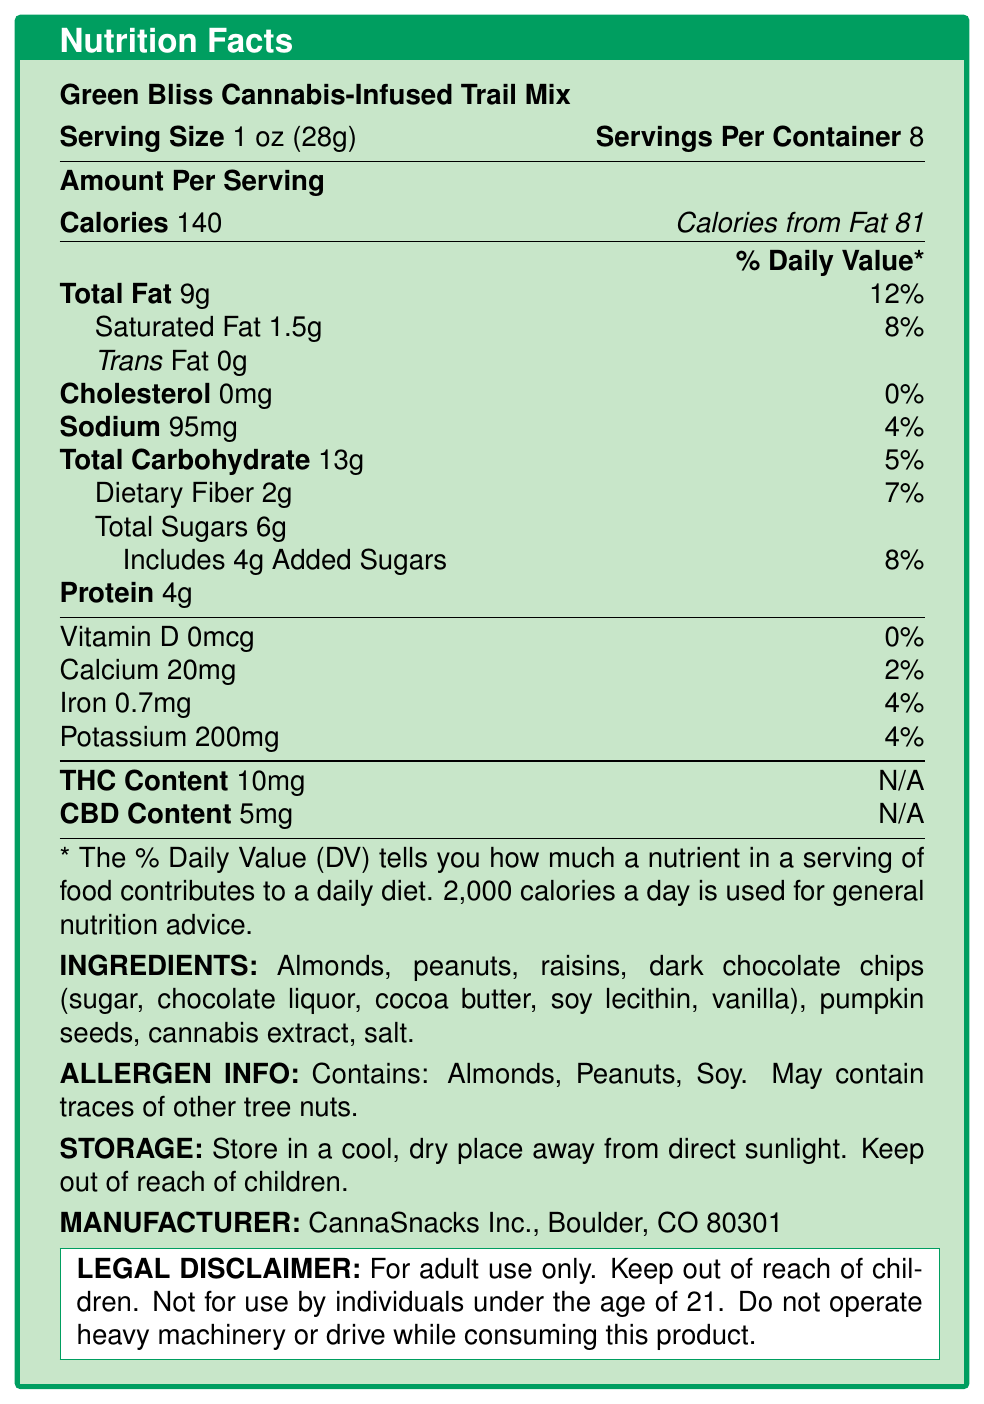what is the serving size for Green Bliss Cannabis-Infused Trail Mix? According to the document, the serving size is listed as "1 oz (28g)".
Answer: 1 oz (28g) how many calories are there per serving? The document states that each serving contains 140 calories.
Answer: 140 what is the total fat content per serving and its daily value percentage? The document specifies that each serving has 9g of total fat, which is 12% of the daily value.
Answer: 9g, 12% how much dietary fiber does each serving contain? According to the document, each serving contains 2g of dietary fiber.
Answer: 2g what are the ingredients in the product? The ingredients are listed clearly under the "INGREDIENTS:" section of the document.
Answer: Almonds, peanuts, raisins, dark chocolate chips (sugar, chocolate liquor, cocoa butter, soy lecithin, vanilla), pumpkin seeds, cannabis extract, salt. how much THC content is in each serving? The document states that each serving contains 10mg of THC.
Answer: 10mg what is the protein content per serving? The document mentions that each serving contains 4g of protein.
Answer: 4g how many servings are there per container? According to the document, there are 8 servings per container.
Answer: 8 how much sodium is in each serving? The document indicates that each serving contains 95mg of sodium.
Answer: 95mg what is the contact information for the manufacturer? The manufacturer's information is listed as "CannaSnacks Inc., Boulder, CO 80301".
Answer: CannaSnacks Inc., Boulder, CO 80301 what percentage of the recommended daily value of calcium does each serving provide? The document specifies that each serving provides 2% of the daily value of calcium.
Answer: 2% what does the legal disclaimer state about the use of the product? The legal disclaimer in the document contains these warnings.
Answer: For adult use only. Keep out of reach of children. Not for use by individuals under the age of 21. Do not operate heavy machinery or drive while consuming this product. which nutrient has the highest daily value percentage per serving? A. Total Fat B. Sodium C. Total Carbohydrate D. Protein Total fat has a daily value percentage of 12%, which is the highest among the listed options.
Answer: A. Total Fat how does the calorie content of Green Bliss Cannabis-Infused Trail Mix compare to a non-infused alternative? A. +5 calories B. +10 calories C. +15 calories D. -5 calories The document mentions a "calories_difference" of "+10" compared to the non-infused alternative.
Answer: B. +10 calories is the product safe for individuals under the age of 21? The legal disclaimer clearly states that the product is not for use by individuals under the age of 21.
Answer: No summarize the information found in the nutrition facts label. This summary encapsulates the nutritional data, ingredient list, manufacturer details, and legal warnings from the document.
Answer: Green Bliss Cannabis-Infused Trail Mix provides 140 calories per 1 oz (28g) serving, with 9g of total fat, 13g of carbohydrates, 4g of protein, and 10mg of THC. Each container holds 8 servings. The mix includes ingredients like almonds, peanuts, raisins, dark chocolate chips, and cannabis extract. It's manufactured by CannaSnacks Inc. in Boulder, CO, and is for adult use only with various health and usage warnings. what is the projected market share of the product by 2025? The information about market share is part of the market insights, but details such as specific projections for 2025 are not provided in the nutrition facts label itself.
Answer: Cannot be determined 